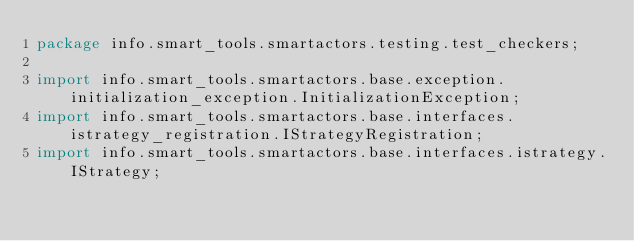<code> <loc_0><loc_0><loc_500><loc_500><_Java_>package info.smart_tools.smartactors.testing.test_checkers;

import info.smart_tools.smartactors.base.exception.initialization_exception.InitializationException;
import info.smart_tools.smartactors.base.interfaces.istrategy_registration.IStrategyRegistration;
import info.smart_tools.smartactors.base.interfaces.istrategy.IStrategy;</code> 